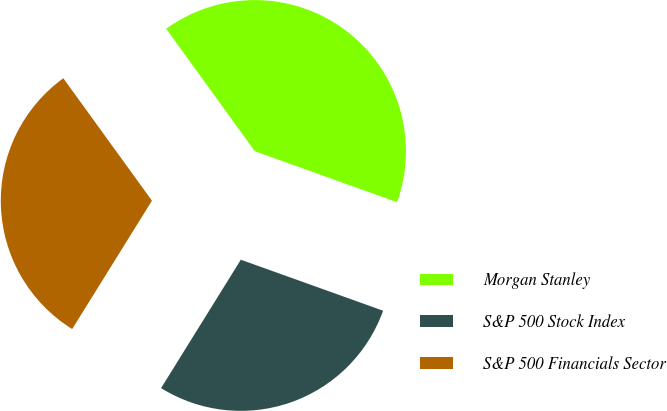Convert chart. <chart><loc_0><loc_0><loc_500><loc_500><pie_chart><fcel>Morgan Stanley<fcel>S&P 500 Stock Index<fcel>S&P 500 Financials Sector<nl><fcel>40.45%<fcel>28.37%<fcel>31.18%<nl></chart> 